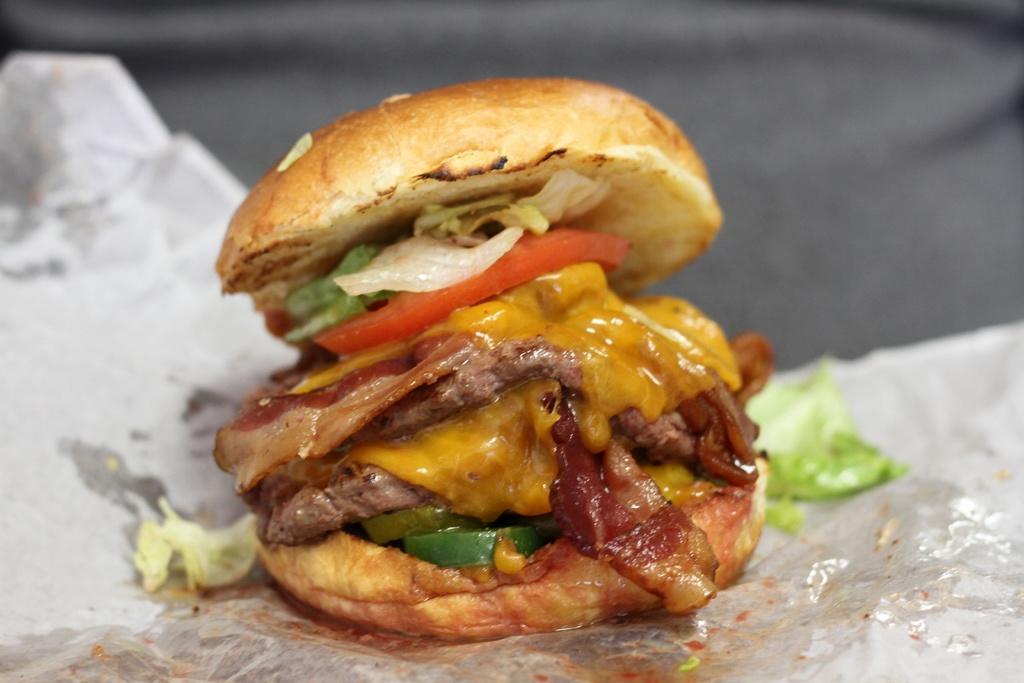Please provide a concise description of this image. In this picture I can see there is a burger and it has cabbage, cheese, slices of tomato and sauces. It is wrapped in a white color paper and in the backdrop I can see there is a grey color surface. 